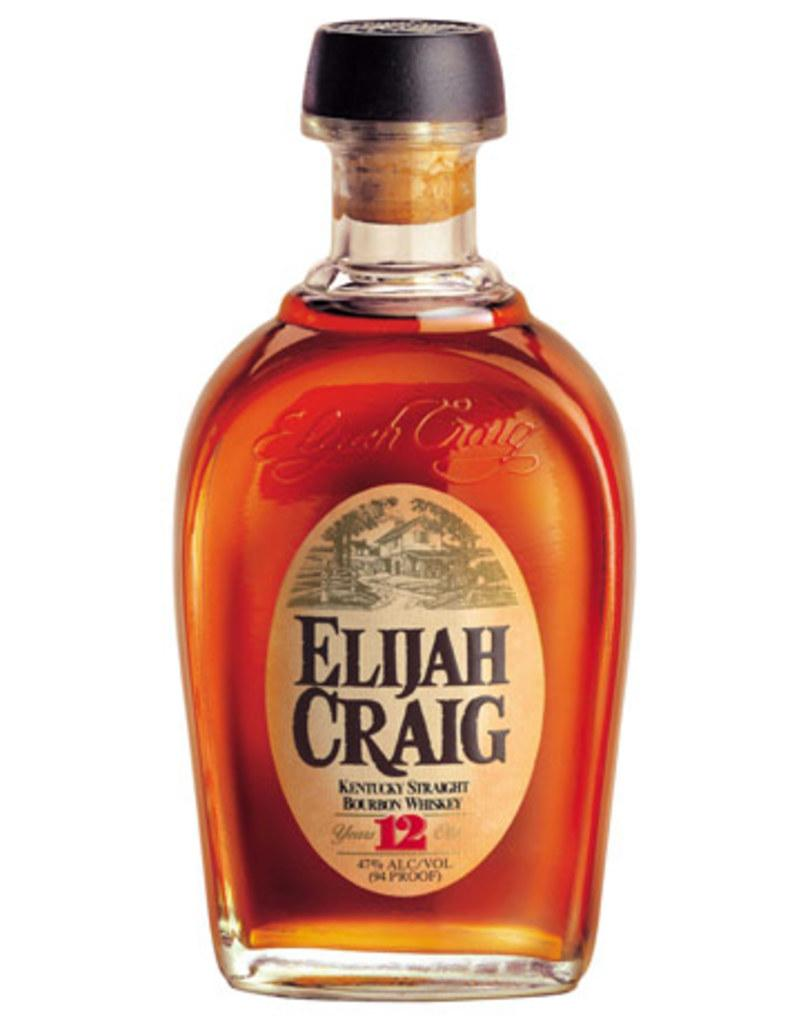<image>
Relay a brief, clear account of the picture shown. A 47% bottle of Kentucky whiskey is made by the brand Elijah Craig. 